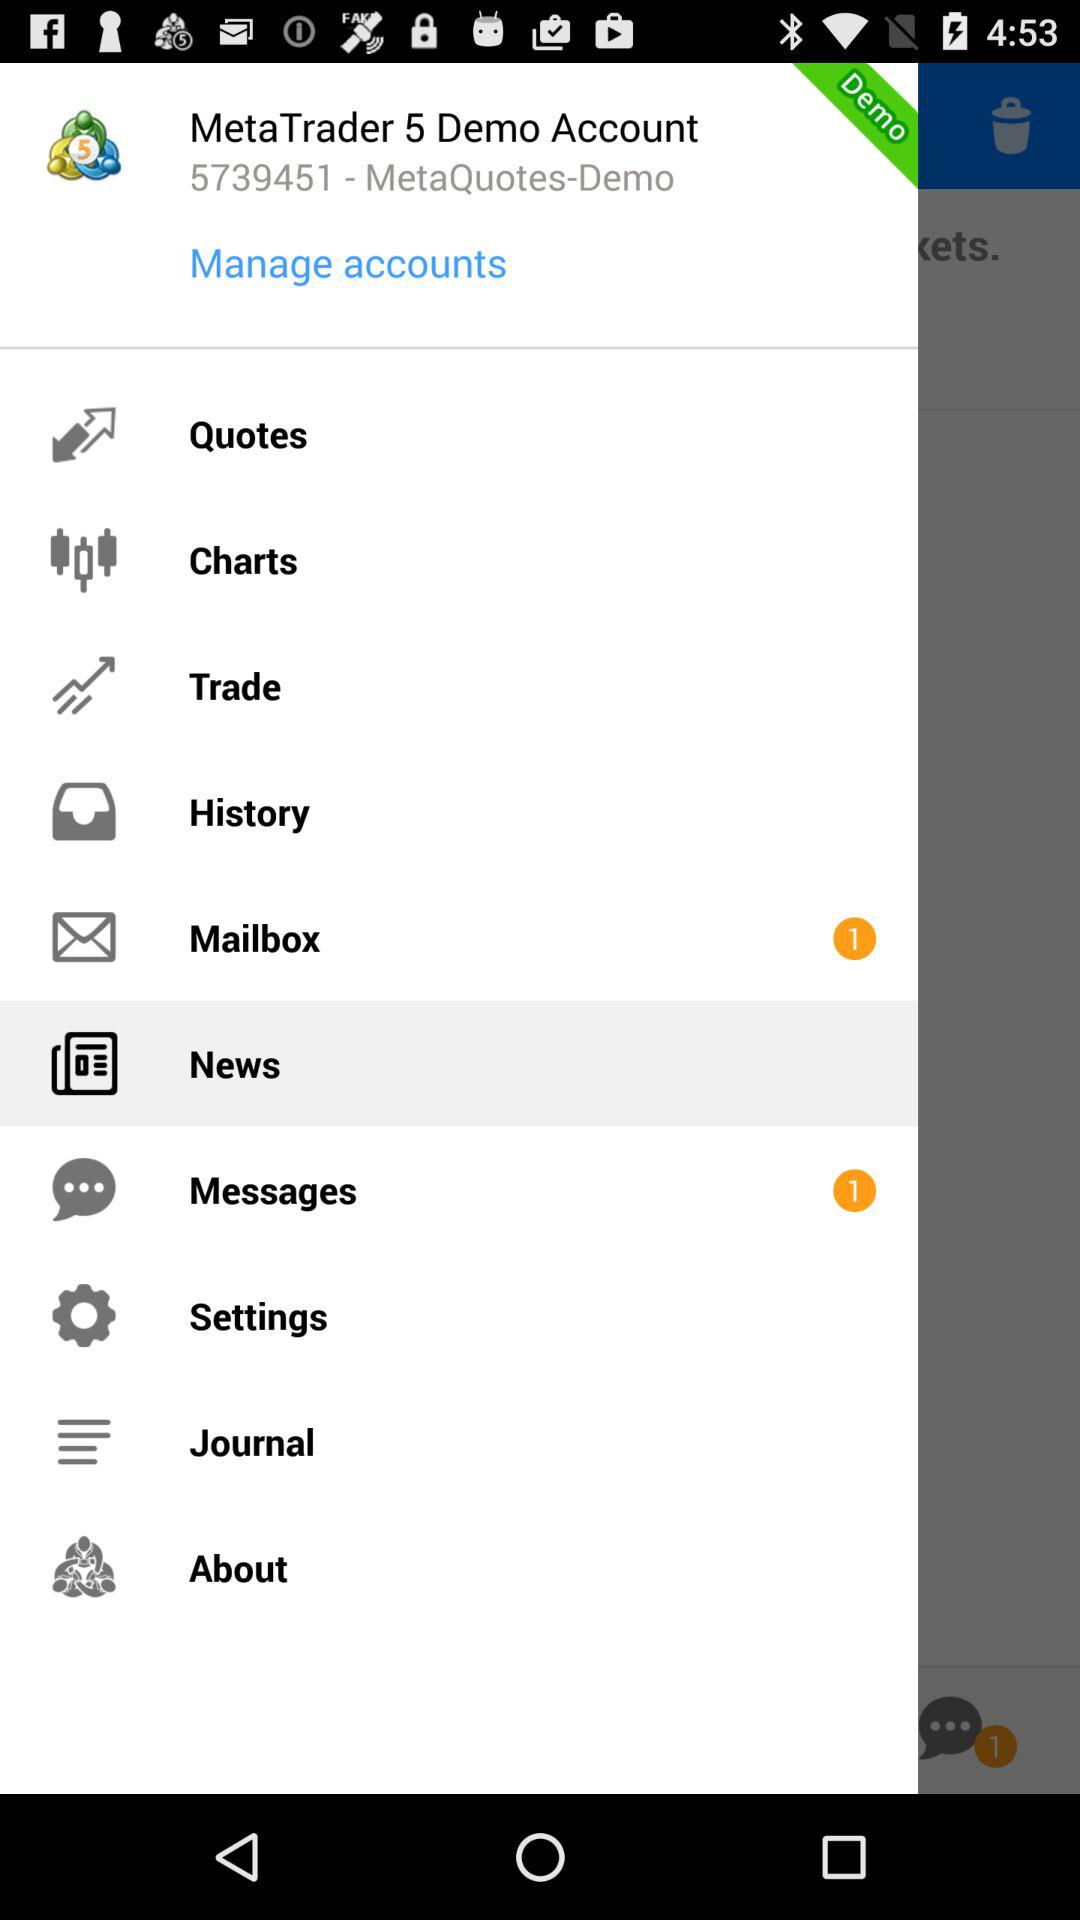How many messages are in the mailbox? There is only 1 message. 